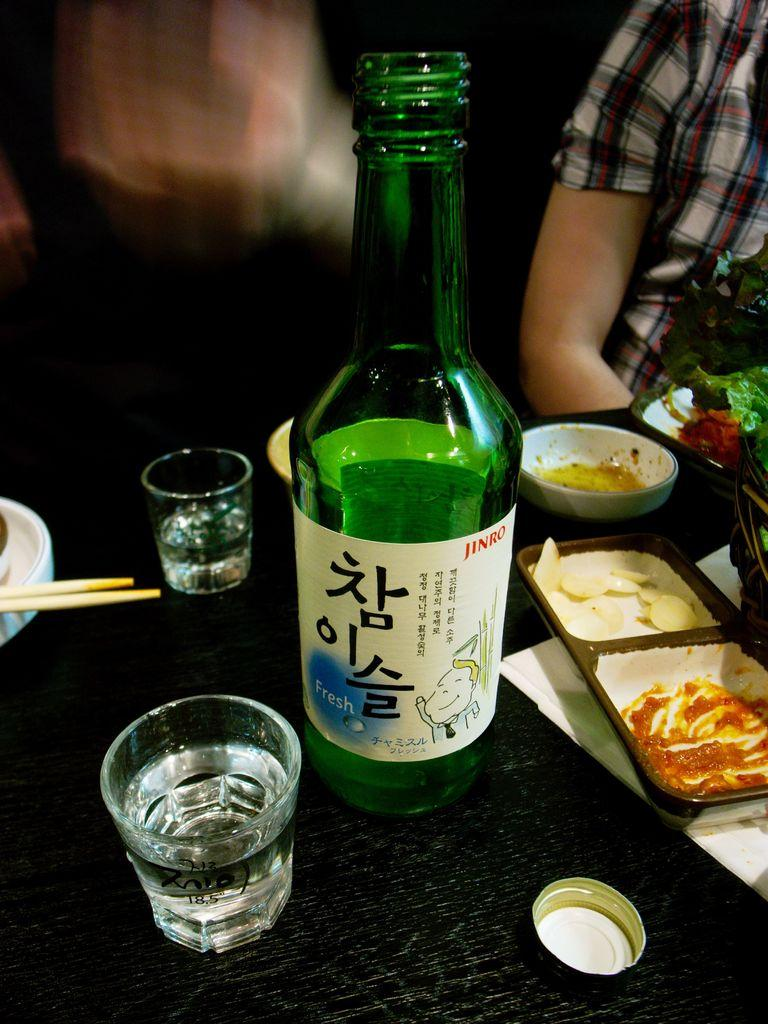Provide a one-sentence caption for the provided image. A bottled beverage, labelled Jinro, is on a table amidst shot glasses and food. 